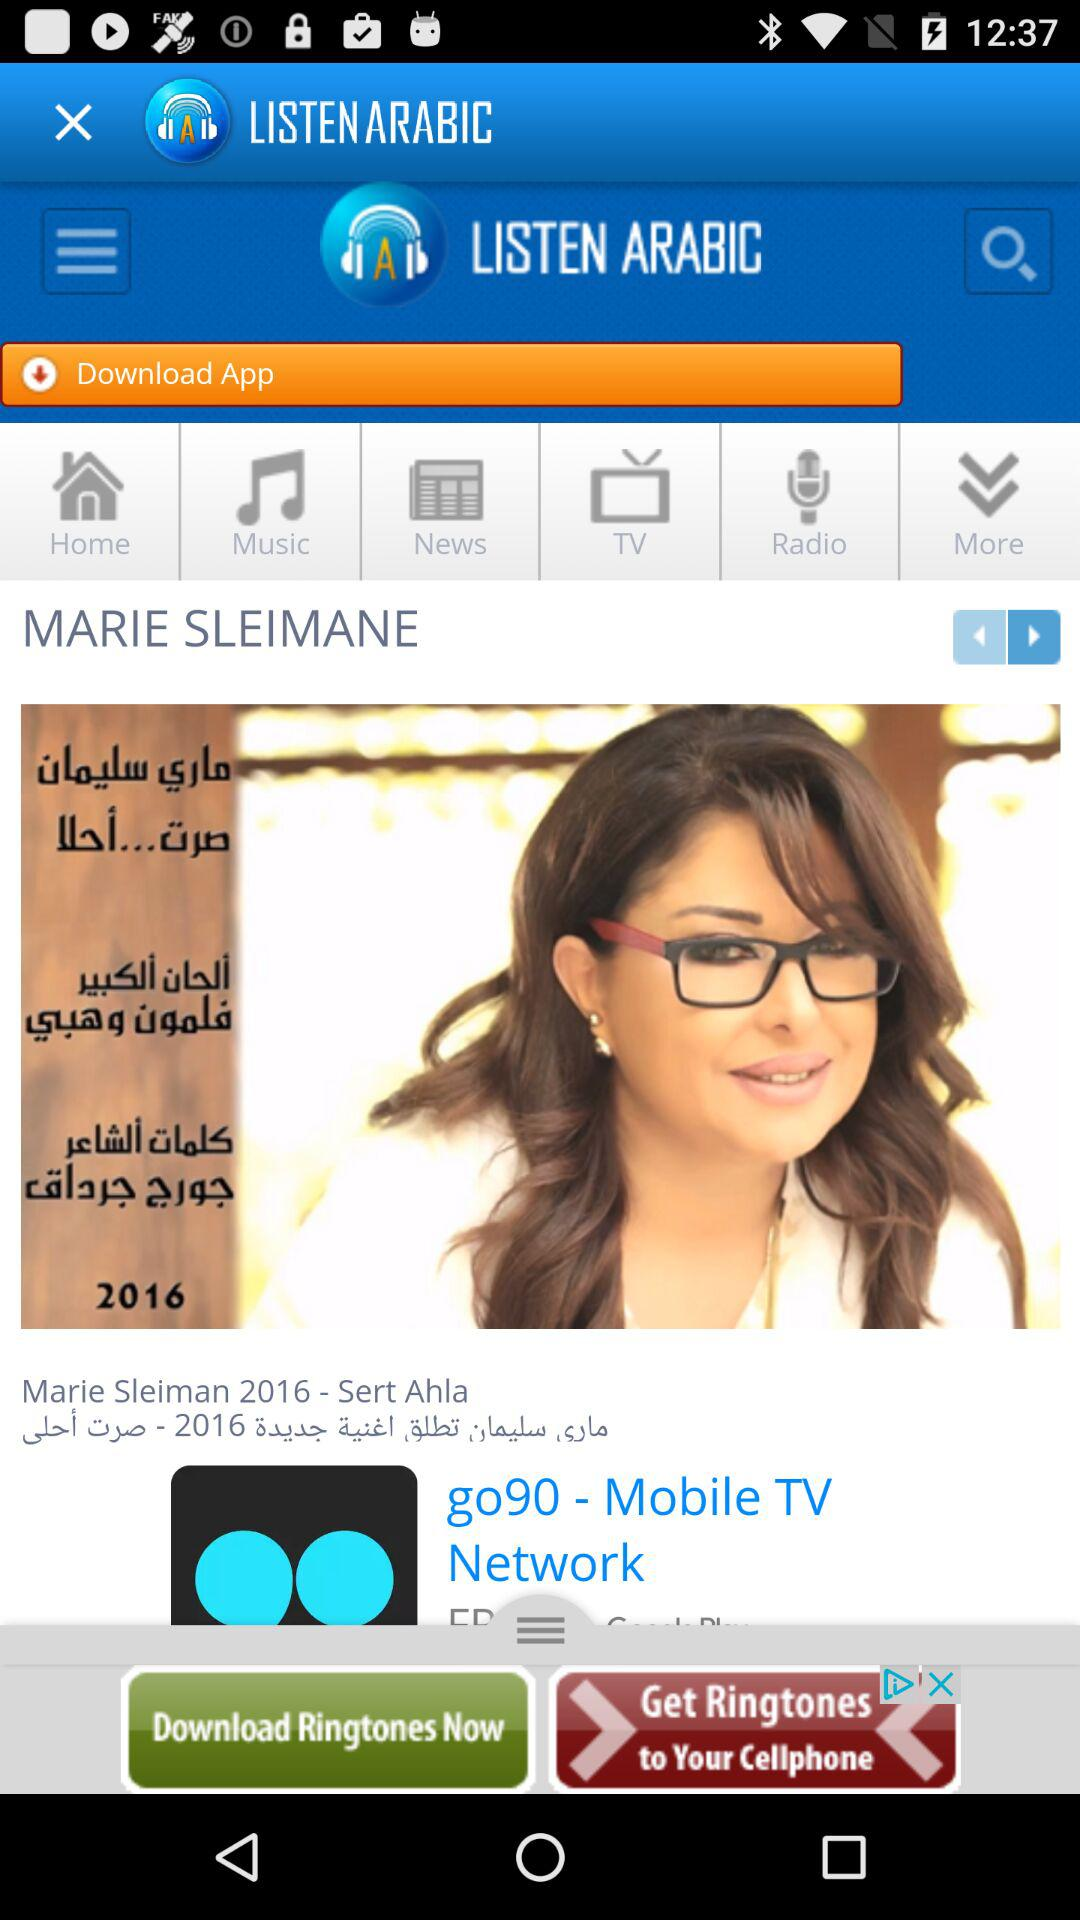Which news story is the headline?
When the provided information is insufficient, respond with <no answer>. <no answer> 